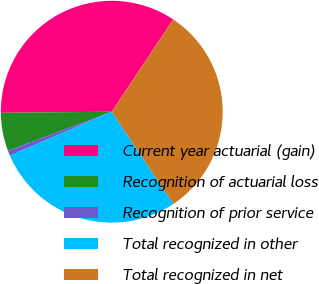Convert chart. <chart><loc_0><loc_0><loc_500><loc_500><pie_chart><fcel>Current year actuarial (gain)<fcel>Recognition of actuarial loss<fcel>Recognition of prior service<fcel>Total recognized in other<fcel>Total recognized in net<nl><fcel>34.49%<fcel>5.58%<fcel>0.73%<fcel>27.9%<fcel>31.29%<nl></chart> 